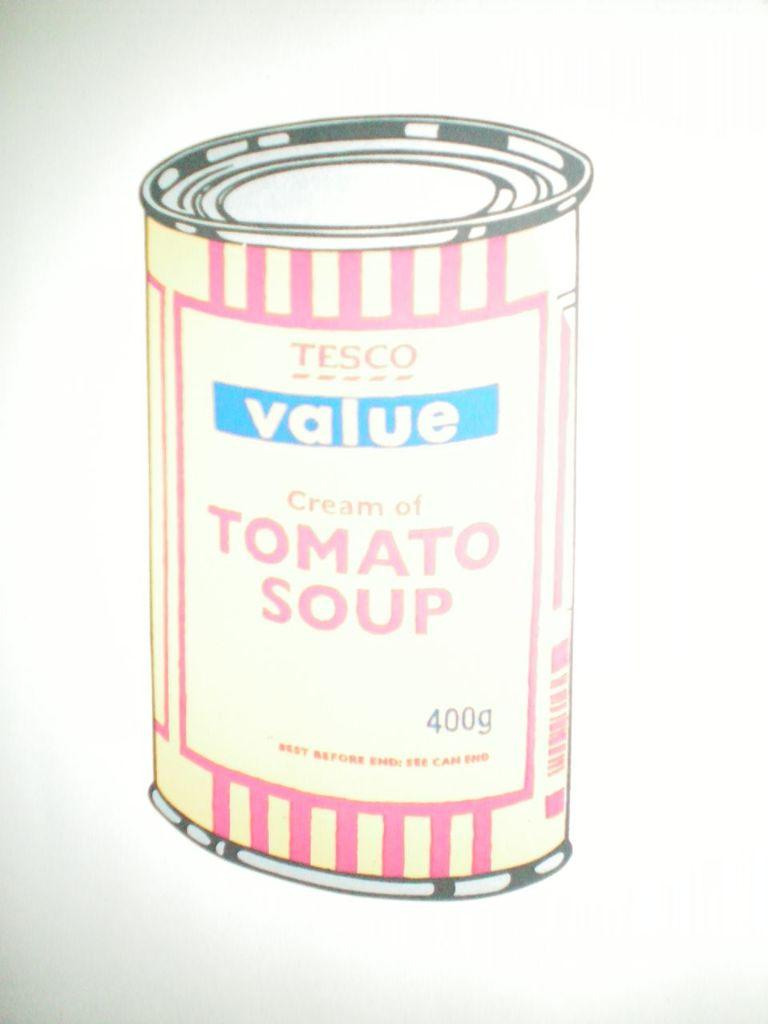<image>
Describe the image concisely. the word value that is on the front of a cabn 